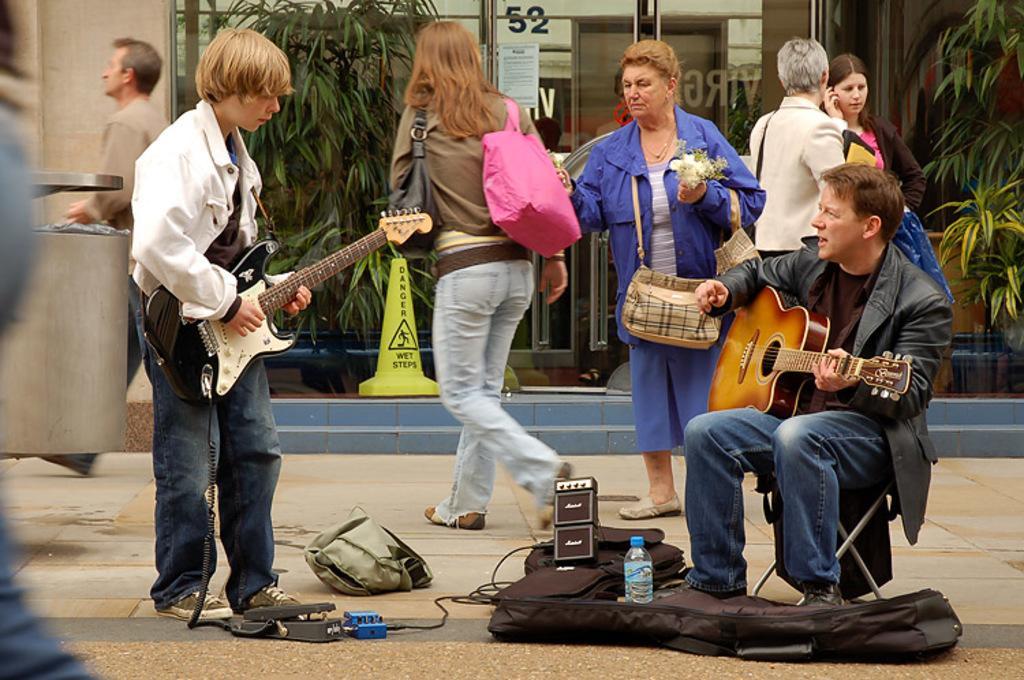In one or two sentences, can you explain what this image depicts? Here is a person sitting and playing guitar and another person standing and playing guitar. These are the guitar bags ,water bottle and some instruments placed on the floor. There are group of people standing and walking. This looks like a glass door of building. These are the small trees. 